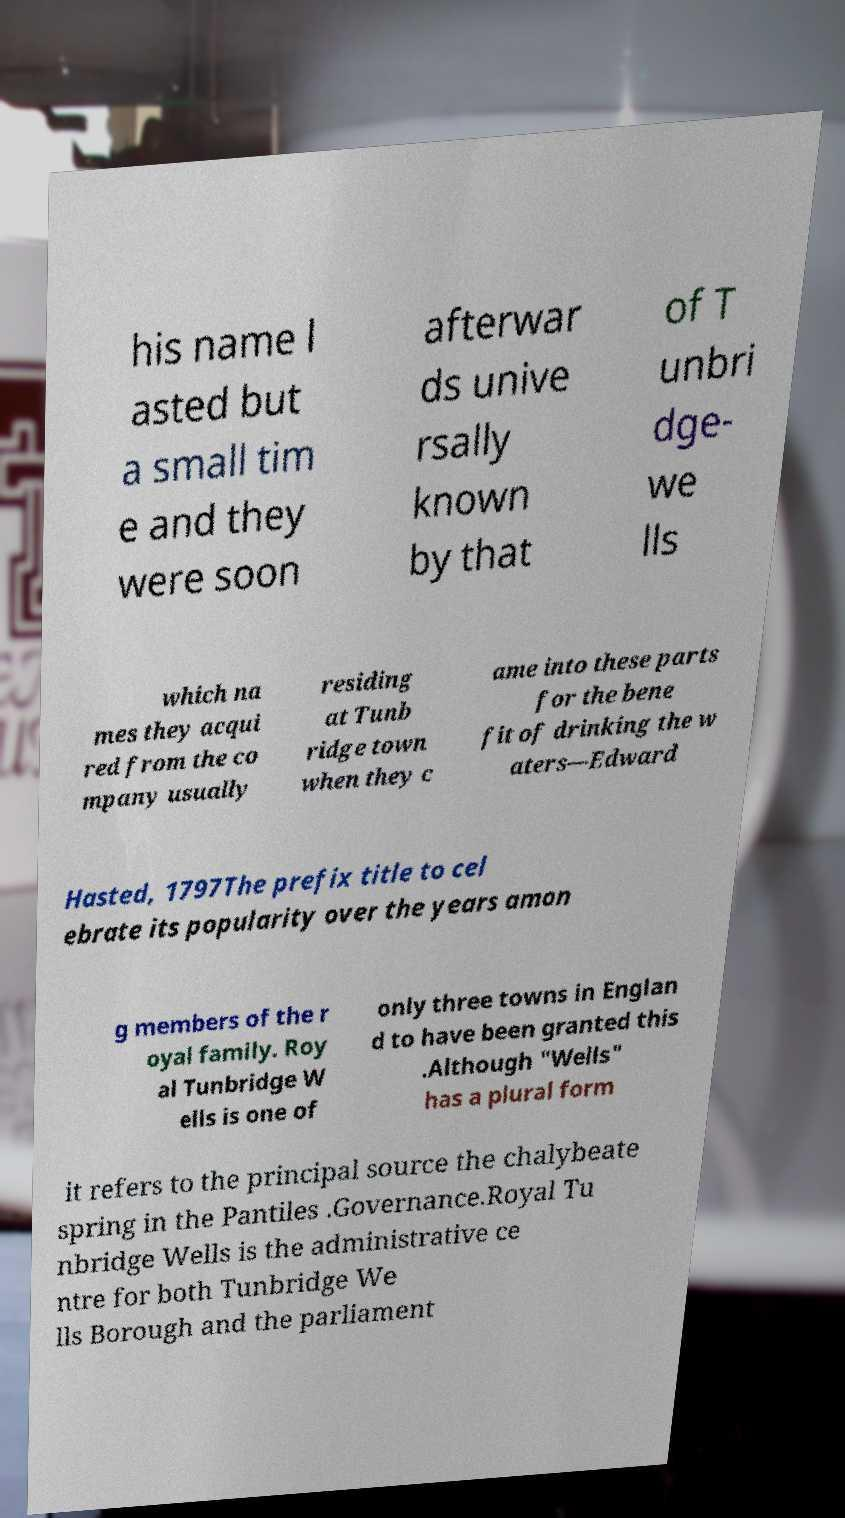Could you extract and type out the text from this image? his name l asted but a small tim e and they were soon afterwar ds unive rsally known by that of T unbri dge- we lls which na mes they acqui red from the co mpany usually residing at Tunb ridge town when they c ame into these parts for the bene fit of drinking the w aters—Edward Hasted, 1797The prefix title to cel ebrate its popularity over the years amon g members of the r oyal family. Roy al Tunbridge W ells is one of only three towns in Englan d to have been granted this .Although "Wells" has a plural form it refers to the principal source the chalybeate spring in the Pantiles .Governance.Royal Tu nbridge Wells is the administrative ce ntre for both Tunbridge We lls Borough and the parliament 